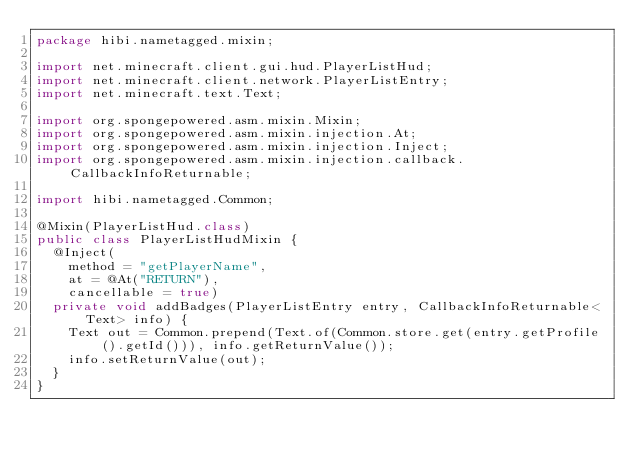Convert code to text. <code><loc_0><loc_0><loc_500><loc_500><_Java_>package hibi.nametagged.mixin;

import net.minecraft.client.gui.hud.PlayerListHud;
import net.minecraft.client.network.PlayerListEntry;
import net.minecraft.text.Text;

import org.spongepowered.asm.mixin.Mixin;
import org.spongepowered.asm.mixin.injection.At;
import org.spongepowered.asm.mixin.injection.Inject;
import org.spongepowered.asm.mixin.injection.callback.CallbackInfoReturnable;

import hibi.nametagged.Common;

@Mixin(PlayerListHud.class)
public class PlayerListHudMixin {
	@Inject(
		method = "getPlayerName",
		at = @At("RETURN"),
		cancellable = true)
	private void addBadges(PlayerListEntry entry, CallbackInfoReturnable<Text> info) {
		Text out = Common.prepend(Text.of(Common.store.get(entry.getProfile().getId())), info.getReturnValue());
		info.setReturnValue(out);
	}
}
</code> 